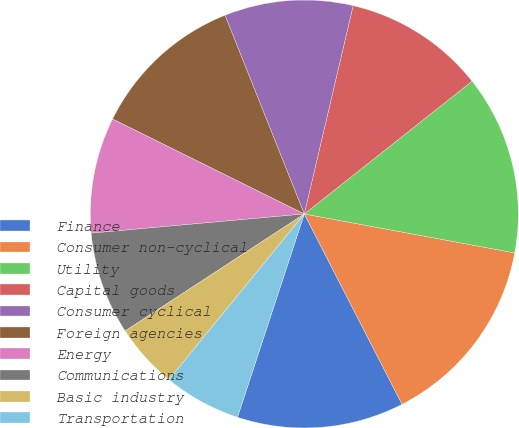Convert chart. <chart><loc_0><loc_0><loc_500><loc_500><pie_chart><fcel>Finance<fcel>Consumer non-cyclical<fcel>Utility<fcel>Capital goods<fcel>Consumer cyclical<fcel>Foreign agencies<fcel>Energy<fcel>Communications<fcel>Basic industry<fcel>Transportation<nl><fcel>12.61%<fcel>14.54%<fcel>13.57%<fcel>10.68%<fcel>9.71%<fcel>11.64%<fcel>8.75%<fcel>7.78%<fcel>4.89%<fcel>5.85%<nl></chart> 